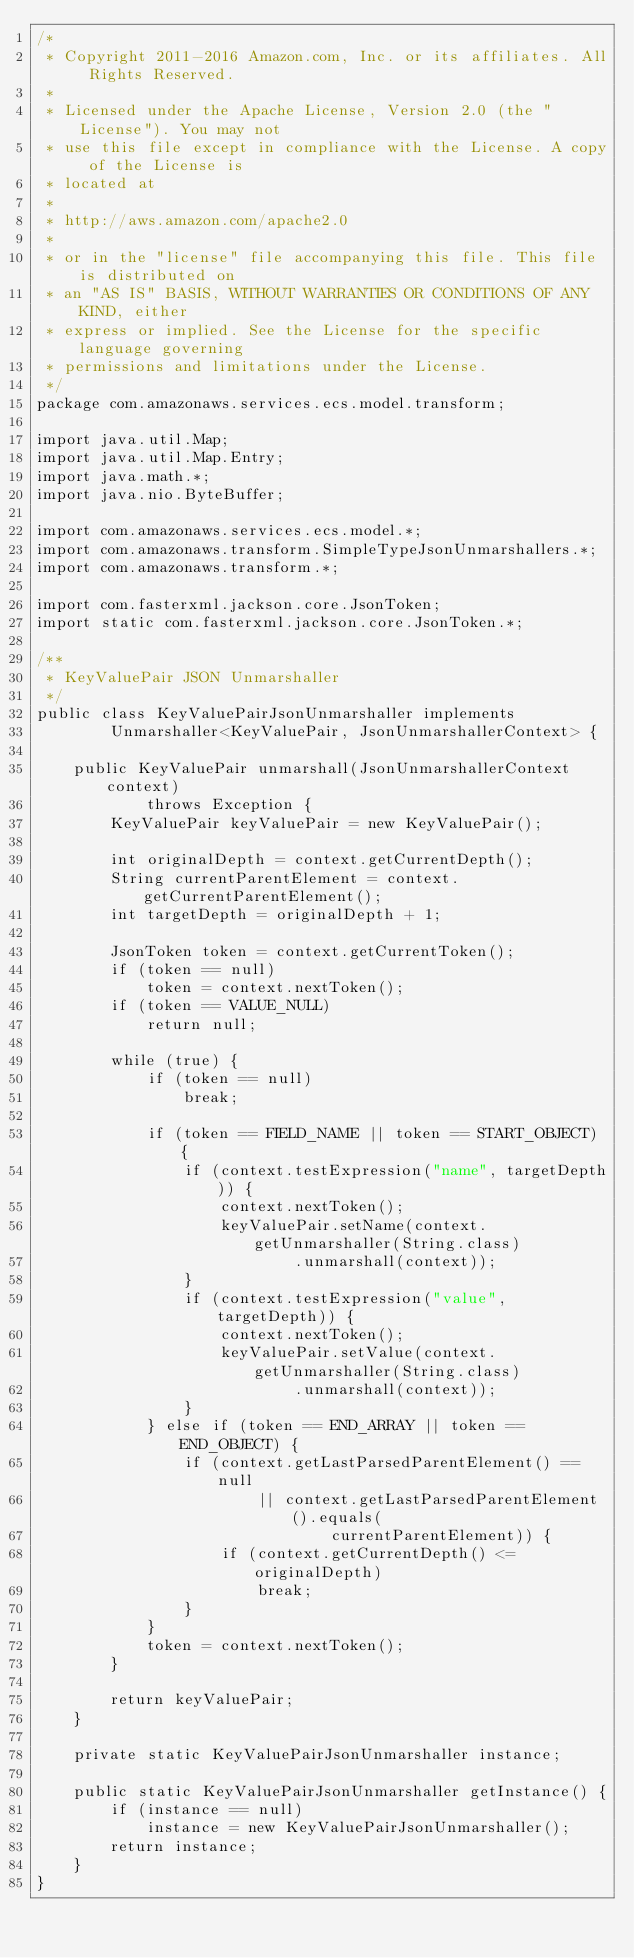<code> <loc_0><loc_0><loc_500><loc_500><_Java_>/*
 * Copyright 2011-2016 Amazon.com, Inc. or its affiliates. All Rights Reserved.
 * 
 * Licensed under the Apache License, Version 2.0 (the "License"). You may not
 * use this file except in compliance with the License. A copy of the License is
 * located at
 * 
 * http://aws.amazon.com/apache2.0
 * 
 * or in the "license" file accompanying this file. This file is distributed on
 * an "AS IS" BASIS, WITHOUT WARRANTIES OR CONDITIONS OF ANY KIND, either
 * express or implied. See the License for the specific language governing
 * permissions and limitations under the License.
 */
package com.amazonaws.services.ecs.model.transform;

import java.util.Map;
import java.util.Map.Entry;
import java.math.*;
import java.nio.ByteBuffer;

import com.amazonaws.services.ecs.model.*;
import com.amazonaws.transform.SimpleTypeJsonUnmarshallers.*;
import com.amazonaws.transform.*;

import com.fasterxml.jackson.core.JsonToken;
import static com.fasterxml.jackson.core.JsonToken.*;

/**
 * KeyValuePair JSON Unmarshaller
 */
public class KeyValuePairJsonUnmarshaller implements
        Unmarshaller<KeyValuePair, JsonUnmarshallerContext> {

    public KeyValuePair unmarshall(JsonUnmarshallerContext context)
            throws Exception {
        KeyValuePair keyValuePair = new KeyValuePair();

        int originalDepth = context.getCurrentDepth();
        String currentParentElement = context.getCurrentParentElement();
        int targetDepth = originalDepth + 1;

        JsonToken token = context.getCurrentToken();
        if (token == null)
            token = context.nextToken();
        if (token == VALUE_NULL)
            return null;

        while (true) {
            if (token == null)
                break;

            if (token == FIELD_NAME || token == START_OBJECT) {
                if (context.testExpression("name", targetDepth)) {
                    context.nextToken();
                    keyValuePair.setName(context.getUnmarshaller(String.class)
                            .unmarshall(context));
                }
                if (context.testExpression("value", targetDepth)) {
                    context.nextToken();
                    keyValuePair.setValue(context.getUnmarshaller(String.class)
                            .unmarshall(context));
                }
            } else if (token == END_ARRAY || token == END_OBJECT) {
                if (context.getLastParsedParentElement() == null
                        || context.getLastParsedParentElement().equals(
                                currentParentElement)) {
                    if (context.getCurrentDepth() <= originalDepth)
                        break;
                }
            }
            token = context.nextToken();
        }

        return keyValuePair;
    }

    private static KeyValuePairJsonUnmarshaller instance;

    public static KeyValuePairJsonUnmarshaller getInstance() {
        if (instance == null)
            instance = new KeyValuePairJsonUnmarshaller();
        return instance;
    }
}
</code> 